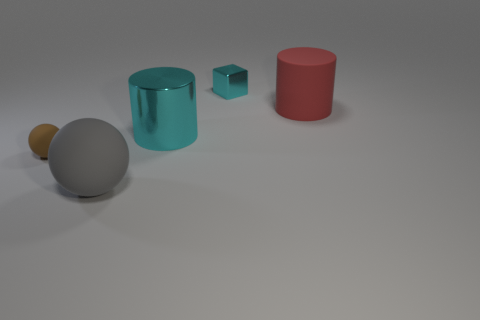Add 3 big red cylinders. How many objects exist? 8 Subtract all cylinders. How many objects are left? 3 Add 5 blue blocks. How many blue blocks exist? 5 Subtract 0 gray cylinders. How many objects are left? 5 Subtract all brown spheres. Subtract all matte cylinders. How many objects are left? 3 Add 5 blocks. How many blocks are left? 6 